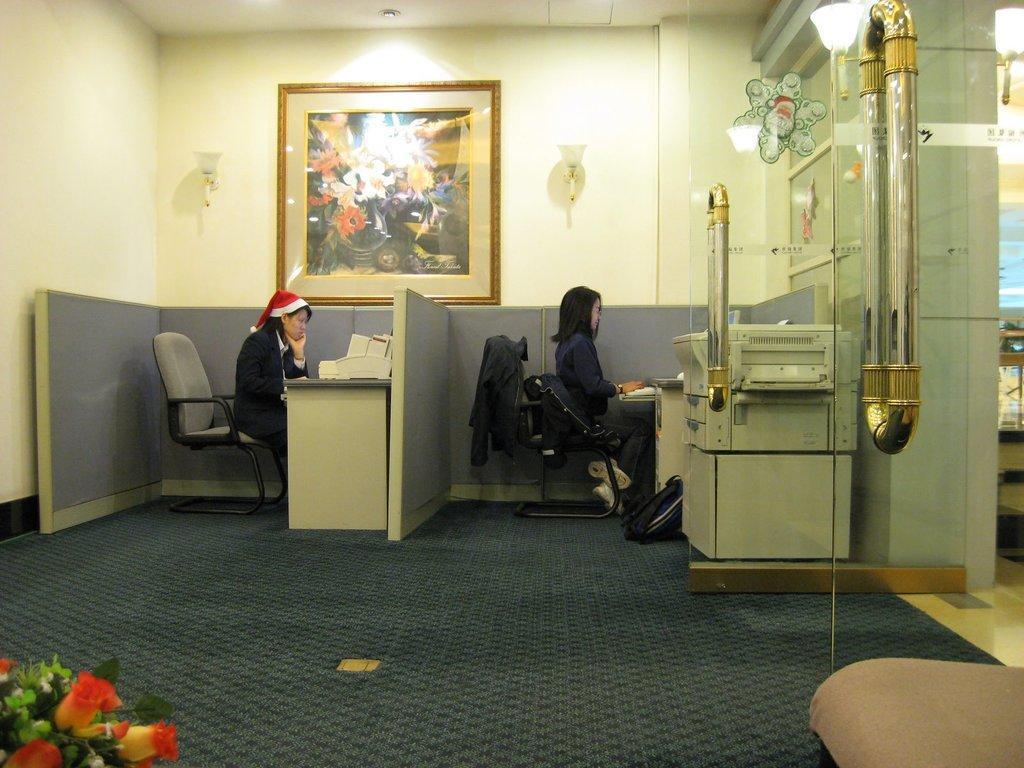Please provide a concise description of this image. In the picture it looks like a work space there are two women they are sitting in the different cabins there are some machines in front of them,to the left side to the wall there is a photo frame and two lights on the either side,to the right side there is a xerox machine and beside that there is a door. 